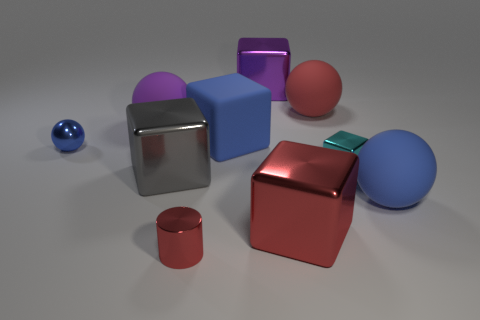There is a blue thing that is both on the right side of the large gray metal block and to the left of the big red cube; what material is it?
Offer a very short reply. Rubber. Do the blue thing that is in front of the tiny block and the large red rubber thing have the same shape?
Give a very brief answer. Yes. Is the number of big blue blocks less than the number of green metal cubes?
Offer a very short reply. No. What number of shiny spheres are the same color as the tiny cylinder?
Your response must be concise. 0. What is the material of the large block that is the same color as the shiny sphere?
Your answer should be very brief. Rubber. Does the rubber cube have the same color as the matte thing in front of the small cube?
Keep it short and to the point. Yes. Are there more small red spheres than tiny cyan metallic cubes?
Offer a terse response. No. There is a purple metallic object that is the same shape as the cyan metallic thing; what size is it?
Provide a short and direct response. Large. Are the small blue object and the thing right of the small block made of the same material?
Provide a short and direct response. No. What number of things are either big rubber spheres or small blue matte blocks?
Make the answer very short. 3. 